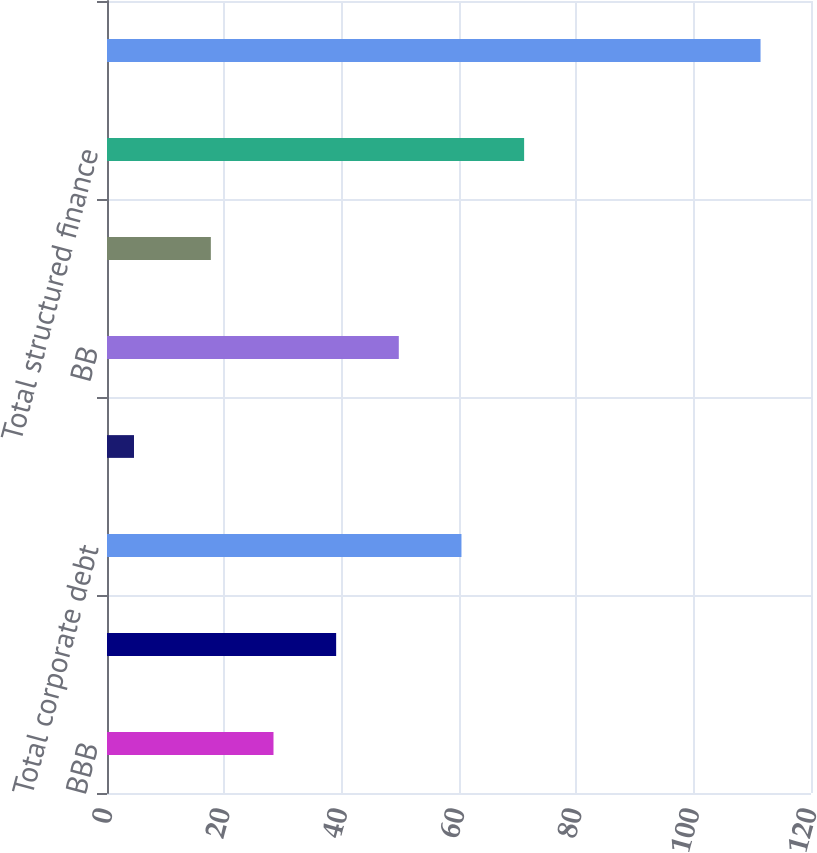Convert chart to OTSL. <chart><loc_0><loc_0><loc_500><loc_500><bar_chart><fcel>BBB<fcel>B<fcel>Total corporate debt<fcel>AA<fcel>BB<fcel>CCC<fcel>Total structured finance<fcel>Total fixed maturities with<nl><fcel>28.38<fcel>39.06<fcel>60.42<fcel>4.6<fcel>49.74<fcel>17.7<fcel>71.1<fcel>111.4<nl></chart> 